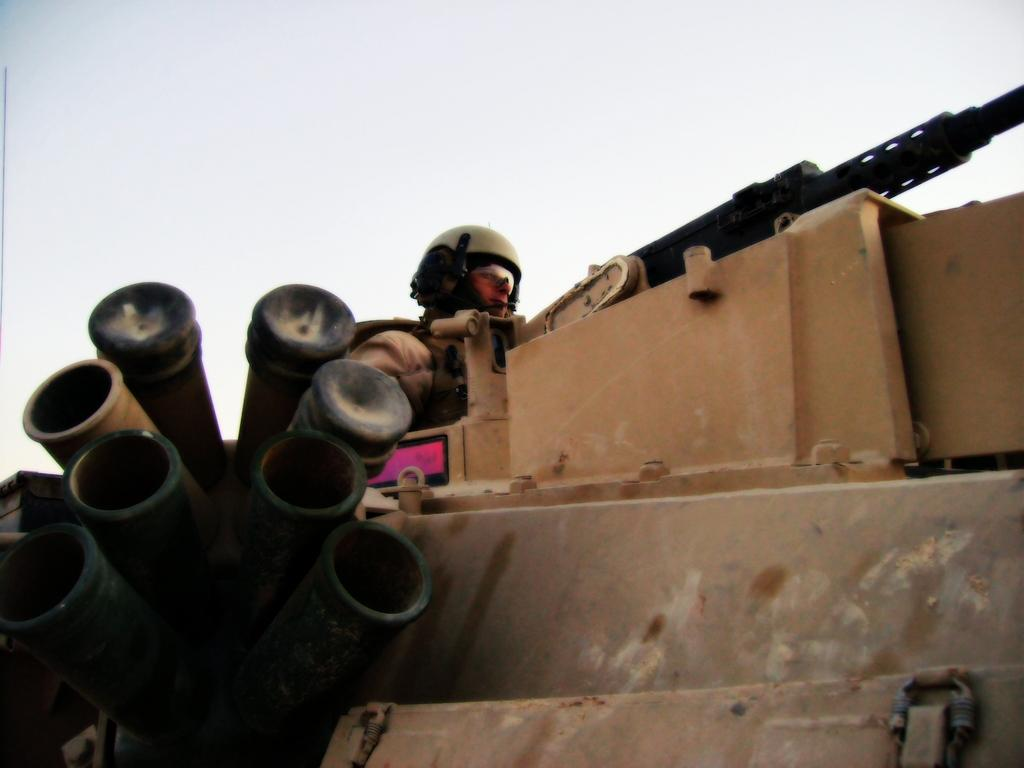What is the main subject of the image? The main subject of the image is a war tank. Is there anyone inside the war tank? Yes, a person is sitting in the war tank. What protective gear is the person wearing? The person is wearing a helmet. Can you see a flock of birds flying near the war tank in the image? There is no mention of birds or a flock in the image, so we cannot confirm their presence. 